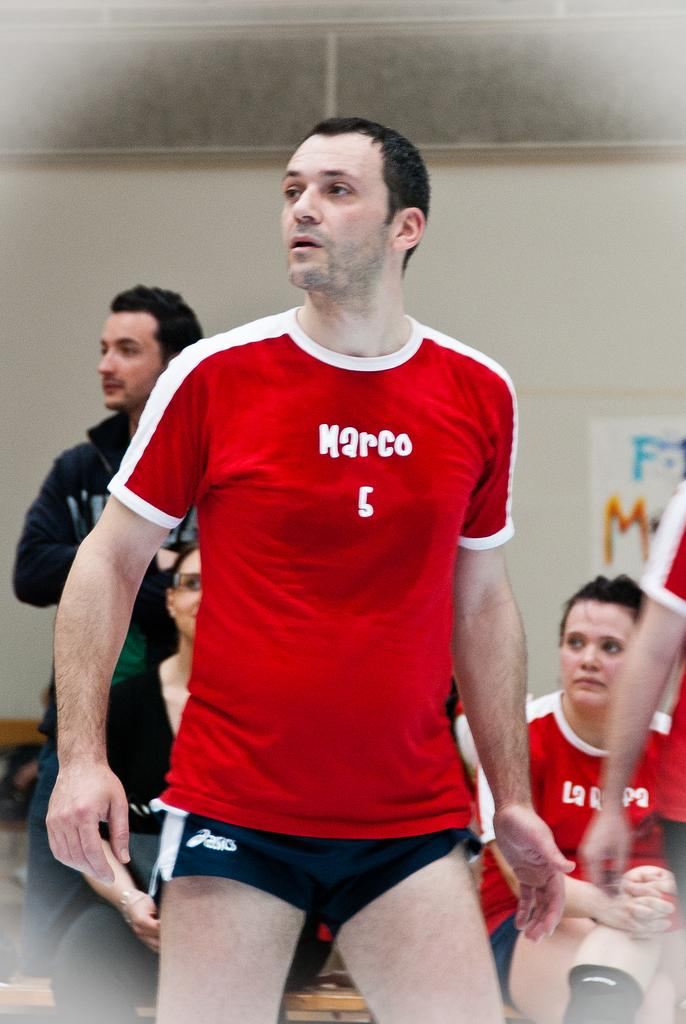<image>
Describe the image concisely. A man is wearing a red shirt with the name marco on it and looks to his right. 